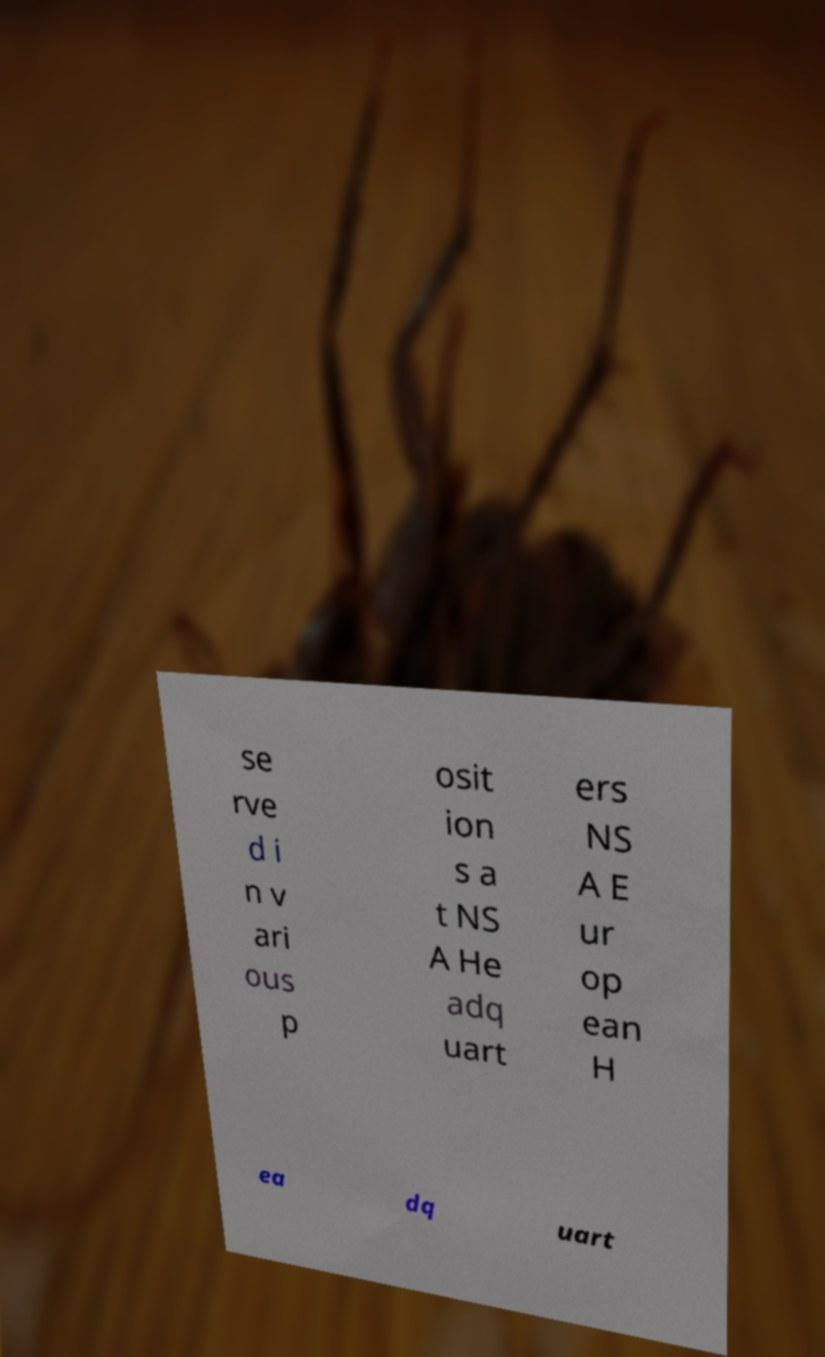Can you accurately transcribe the text from the provided image for me? se rve d i n v ari ous p osit ion s a t NS A He adq uart ers NS A E ur op ean H ea dq uart 